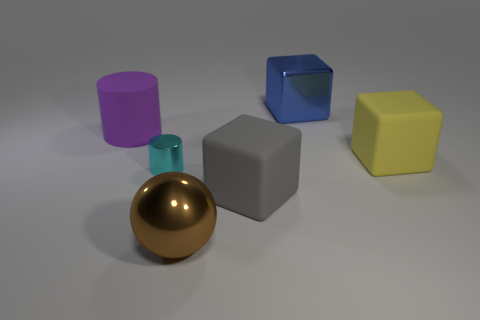If I were to touch the objects, what textures might I expect? If you were to touch the objects, you can expect varying textures. The yellow and blue cubes and the gray block might feel smooth and possibly cold if they are made of materials such as plastic or metal. The gold sphere would likely feel similar but with a noticeably reflective and slick surface. The pink cylinder might feel smooth as well, though the texture would depend on its actual material, which isn't as clearly indicated through visual cues alone. 